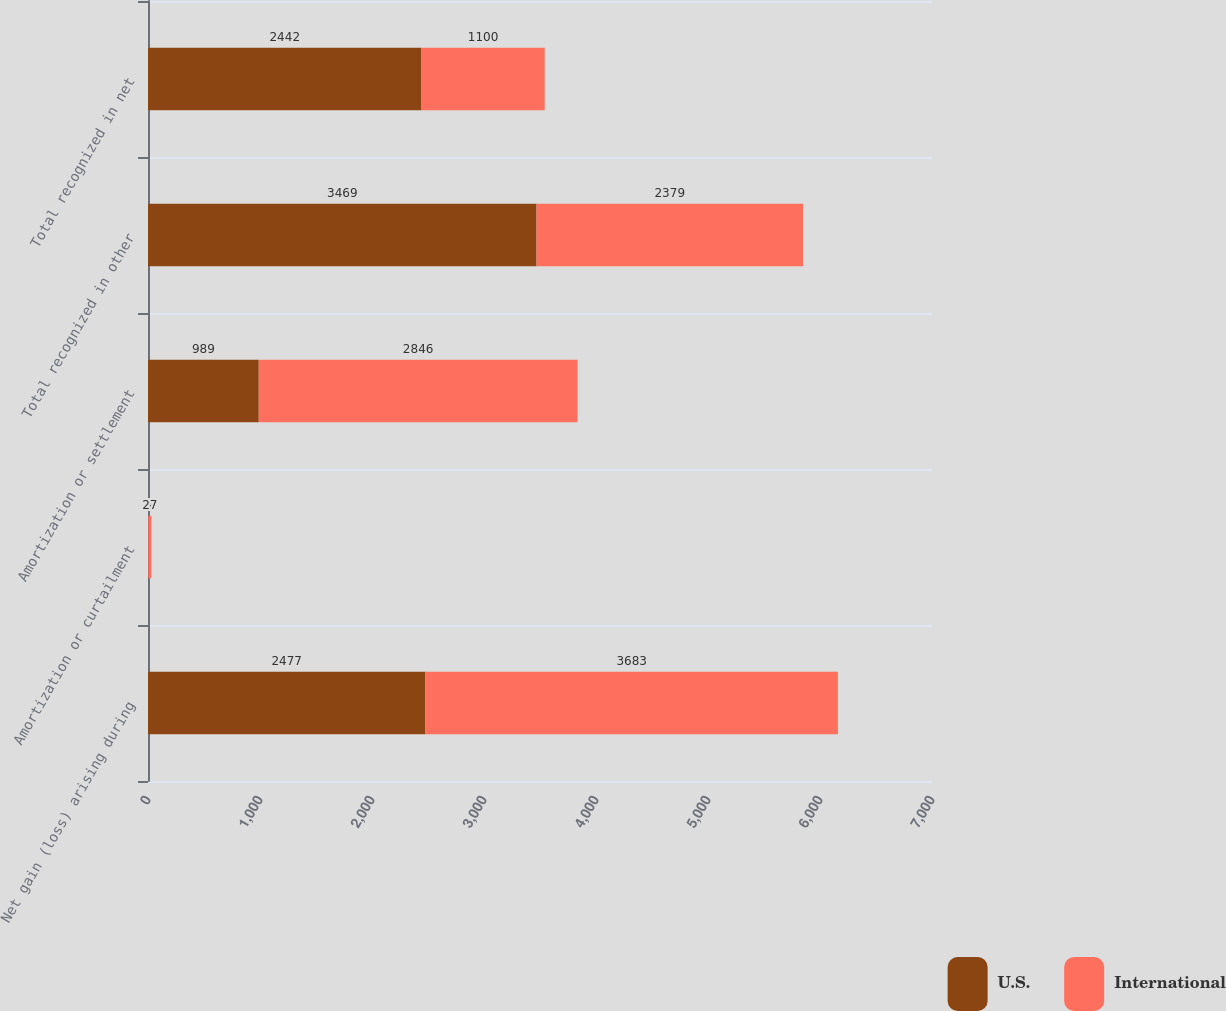Convert chart. <chart><loc_0><loc_0><loc_500><loc_500><stacked_bar_chart><ecel><fcel>Net gain (loss) arising during<fcel>Amortization or curtailment<fcel>Amortization or settlement<fcel>Total recognized in other<fcel>Total recognized in net<nl><fcel>U.S.<fcel>2477<fcel>3<fcel>989<fcel>3469<fcel>2442<nl><fcel>International<fcel>3683<fcel>27<fcel>2846<fcel>2379<fcel>1100<nl></chart> 